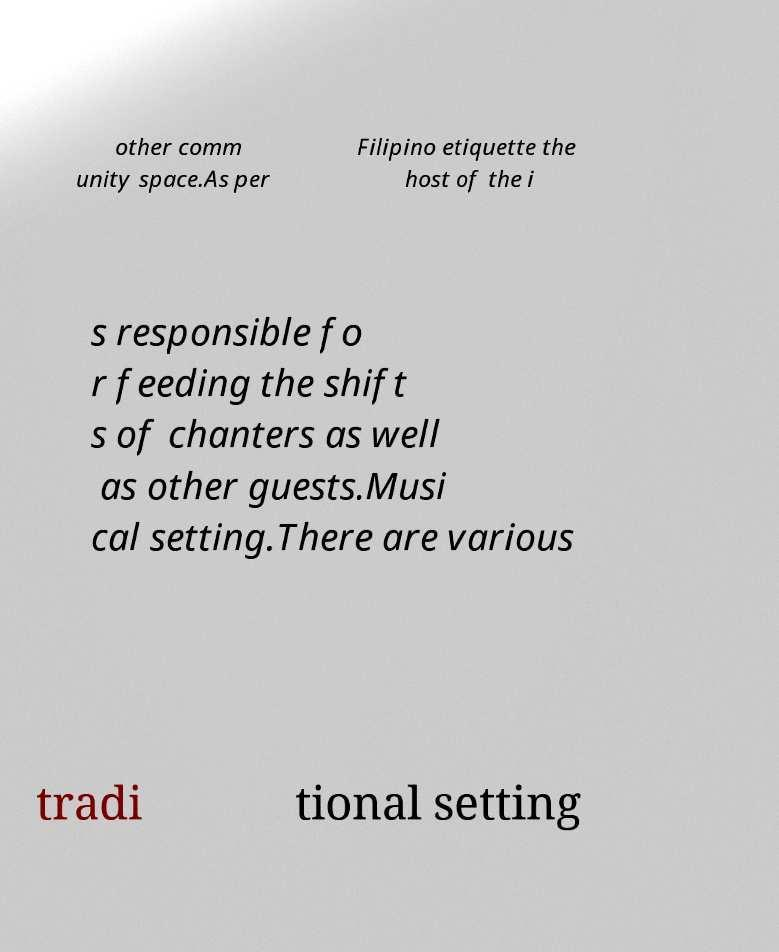Could you extract and type out the text from this image? other comm unity space.As per Filipino etiquette the host of the i s responsible fo r feeding the shift s of chanters as well as other guests.Musi cal setting.There are various tradi tional setting 